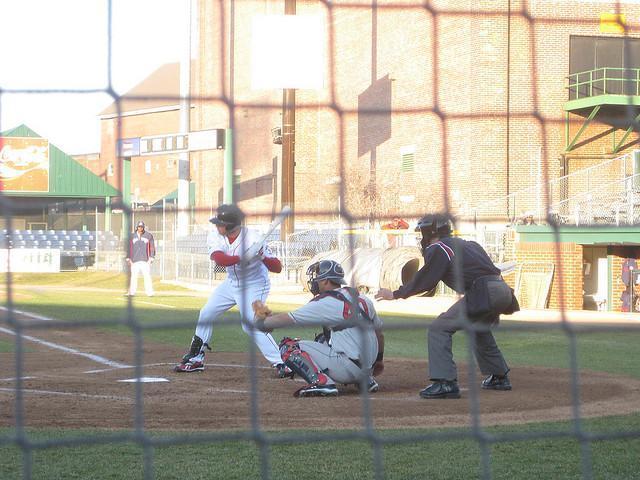How many people are there?
Give a very brief answer. 3. 